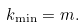<formula> <loc_0><loc_0><loc_500><loc_500>k _ { \min } = m .</formula> 